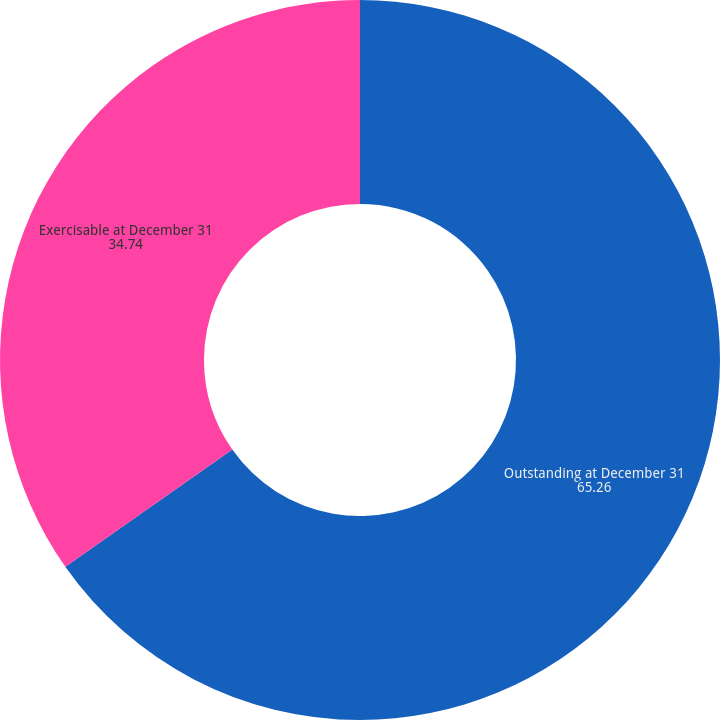Convert chart. <chart><loc_0><loc_0><loc_500><loc_500><pie_chart><fcel>Outstanding at December 31<fcel>Exercisable at December 31<nl><fcel>65.26%<fcel>34.74%<nl></chart> 